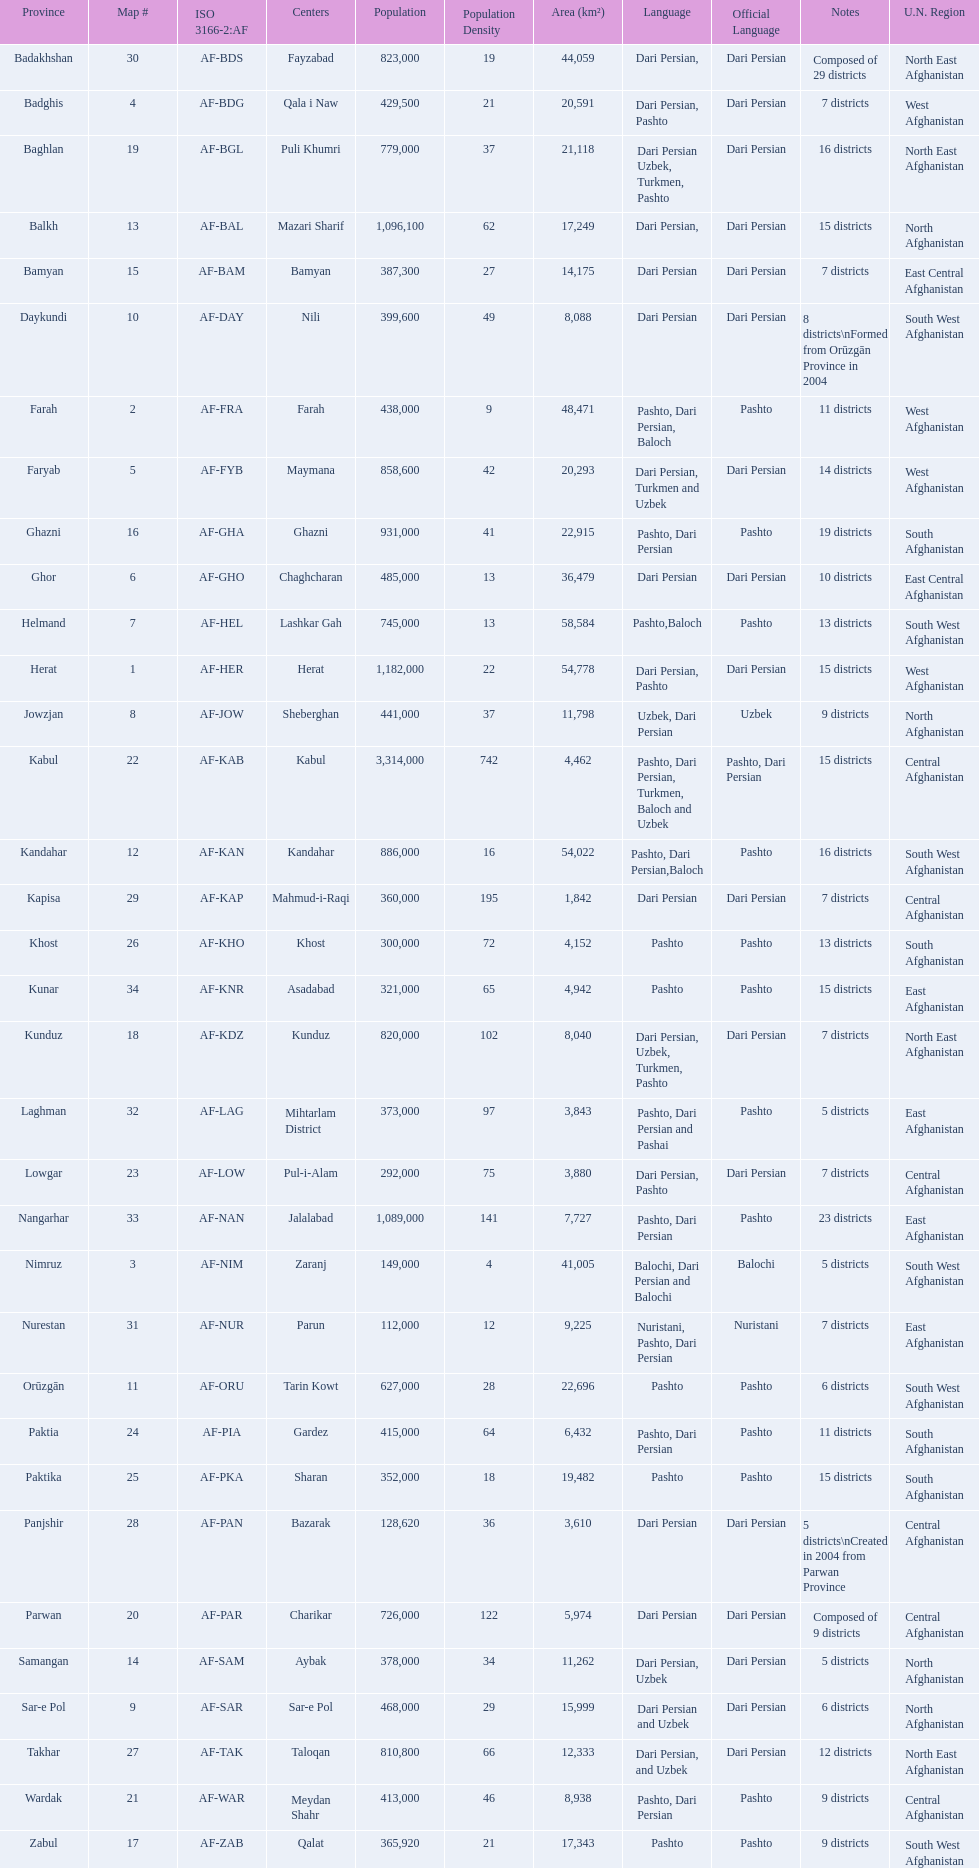How many provinces in afghanistan speak dari persian? 28. Could you parse the entire table as a dict? {'header': ['Province', 'Map #', 'ISO 3166-2:AF', 'Centers', 'Population', 'Population Density', 'Area (km²)', 'Language', 'Official Language', 'Notes', 'U.N. Region'], 'rows': [['Badakhshan', '30', 'AF-BDS', 'Fayzabad', '823,000', '19', '44,059', 'Dari Persian,', 'Dari Persian', 'Composed of 29 districts', 'North East Afghanistan'], ['Badghis', '4', 'AF-BDG', 'Qala i Naw', '429,500', '21', '20,591', 'Dari Persian, Pashto', 'Dari Persian', '7 districts', 'West Afghanistan'], ['Baghlan', '19', 'AF-BGL', 'Puli Khumri', '779,000', '37', '21,118', 'Dari Persian Uzbek, Turkmen, Pashto', 'Dari Persian', '16 districts', 'North East Afghanistan'], ['Balkh', '13', 'AF-BAL', 'Mazari Sharif', '1,096,100', '62', '17,249', 'Dari Persian,', 'Dari Persian', '15 districts', 'North Afghanistan'], ['Bamyan', '15', 'AF-BAM', 'Bamyan', '387,300', '27', '14,175', 'Dari Persian', 'Dari Persian', '7 districts', 'East Central Afghanistan'], ['Daykundi', '10', 'AF-DAY', 'Nili', '399,600', '49', '8,088', 'Dari Persian', 'Dari Persian', '8 districts\\nFormed from Orūzgān Province in 2004', 'South West Afghanistan'], ['Farah', '2', 'AF-FRA', 'Farah', '438,000', '9', '48,471', 'Pashto, Dari Persian, Baloch', 'Pashto', '11 districts', 'West Afghanistan'], ['Faryab', '5', 'AF-FYB', 'Maymana', '858,600', '42', '20,293', 'Dari Persian, Turkmen and Uzbek', 'Dari Persian', '14 districts', 'West Afghanistan'], ['Ghazni', '16', 'AF-GHA', 'Ghazni', '931,000', '41', '22,915', 'Pashto, Dari Persian', 'Pashto', '19 districts', 'South Afghanistan'], ['Ghor', '6', 'AF-GHO', 'Chaghcharan', '485,000', '13', '36,479', 'Dari Persian', 'Dari Persian', '10 districts', 'East Central Afghanistan'], ['Helmand', '7', 'AF-HEL', 'Lashkar Gah', '745,000', '13', '58,584', 'Pashto,Baloch', 'Pashto', '13 districts', 'South West Afghanistan'], ['Herat', '1', 'AF-HER', 'Herat', '1,182,000', '22', '54,778', 'Dari Persian, Pashto', 'Dari Persian', '15 districts', 'West Afghanistan'], ['Jowzjan', '8', 'AF-JOW', 'Sheberghan', '441,000', '37', '11,798', 'Uzbek, Dari Persian', 'Uzbek', '9 districts', 'North Afghanistan'], ['Kabul', '22', 'AF-KAB', 'Kabul', '3,314,000', '742', '4,462', 'Pashto, Dari Persian, Turkmen, Baloch and Uzbek', 'Pashto, Dari Persian', '15 districts', 'Central Afghanistan'], ['Kandahar', '12', 'AF-KAN', 'Kandahar', '886,000', '16', '54,022', 'Pashto, Dari Persian,Baloch', 'Pashto', '16 districts', 'South West Afghanistan'], ['Kapisa', '29', 'AF-KAP', 'Mahmud-i-Raqi', '360,000', '195', '1,842', 'Dari Persian', 'Dari Persian', '7 districts', 'Central Afghanistan'], ['Khost', '26', 'AF-KHO', 'Khost', '300,000', '72', '4,152', 'Pashto', 'Pashto', '13 districts', 'South Afghanistan'], ['Kunar', '34', 'AF-KNR', 'Asadabad', '321,000', '65', '4,942', 'Pashto', 'Pashto', '15 districts', 'East Afghanistan'], ['Kunduz', '18', 'AF-KDZ', 'Kunduz', '820,000', '102', '8,040', 'Dari Persian, Uzbek, Turkmen, Pashto', 'Dari Persian', '7 districts', 'North East Afghanistan'], ['Laghman', '32', 'AF-LAG', 'Mihtarlam District', '373,000', '97', '3,843', 'Pashto, Dari Persian and Pashai', 'Pashto', '5 districts', 'East Afghanistan'], ['Lowgar', '23', 'AF-LOW', 'Pul-i-Alam', '292,000', '75', '3,880', 'Dari Persian, Pashto', 'Dari Persian', '7 districts', 'Central Afghanistan'], ['Nangarhar', '33', 'AF-NAN', 'Jalalabad', '1,089,000', '141', '7,727', 'Pashto, Dari Persian', 'Pashto', '23 districts', 'East Afghanistan'], ['Nimruz', '3', 'AF-NIM', 'Zaranj', '149,000', '4', '41,005', 'Balochi, Dari Persian and Balochi', 'Balochi', '5 districts', 'South West Afghanistan'], ['Nurestan', '31', 'AF-NUR', 'Parun', '112,000', '12', '9,225', 'Nuristani, Pashto, Dari Persian', 'Nuristani', '7 districts', 'East Afghanistan'], ['Orūzgān', '11', 'AF-ORU', 'Tarin Kowt', '627,000', '28', '22,696', 'Pashto', 'Pashto', '6 districts', 'South West Afghanistan'], ['Paktia', '24', 'AF-PIA', 'Gardez', '415,000', '64', '6,432', 'Pashto, Dari Persian', 'Pashto', '11 districts', 'South Afghanistan'], ['Paktika', '25', 'AF-PKA', 'Sharan', '352,000', '18', '19,482', 'Pashto', 'Pashto', '15 districts', 'South Afghanistan'], ['Panjshir', '28', 'AF-PAN', 'Bazarak', '128,620', '36', '3,610', 'Dari Persian', 'Dari Persian', '5 districts\\nCreated in 2004 from Parwan Province', 'Central Afghanistan'], ['Parwan', '20', 'AF-PAR', 'Charikar', '726,000', '122', '5,974', 'Dari Persian', 'Dari Persian', 'Composed of 9 districts', 'Central Afghanistan'], ['Samangan', '14', 'AF-SAM', 'Aybak', '378,000', '34', '11,262', 'Dari Persian, Uzbek', 'Dari Persian', '5 districts', 'North Afghanistan'], ['Sar-e Pol', '9', 'AF-SAR', 'Sar-e Pol', '468,000', '29', '15,999', 'Dari Persian and Uzbek', 'Dari Persian', '6 districts', 'North Afghanistan'], ['Takhar', '27', 'AF-TAK', 'Taloqan', '810,800', '66', '12,333', 'Dari Persian, and Uzbek', 'Dari Persian', '12 districts', 'North East Afghanistan'], ['Wardak', '21', 'AF-WAR', 'Meydan Shahr', '413,000', '46', '8,938', 'Pashto, Dari Persian', 'Pashto', '9 districts', 'Central Afghanistan'], ['Zabul', '17', 'AF-ZAB', 'Qalat', '365,920', '21', '17,343', 'Pashto', 'Pashto', '9 districts', 'South West Afghanistan']]} 